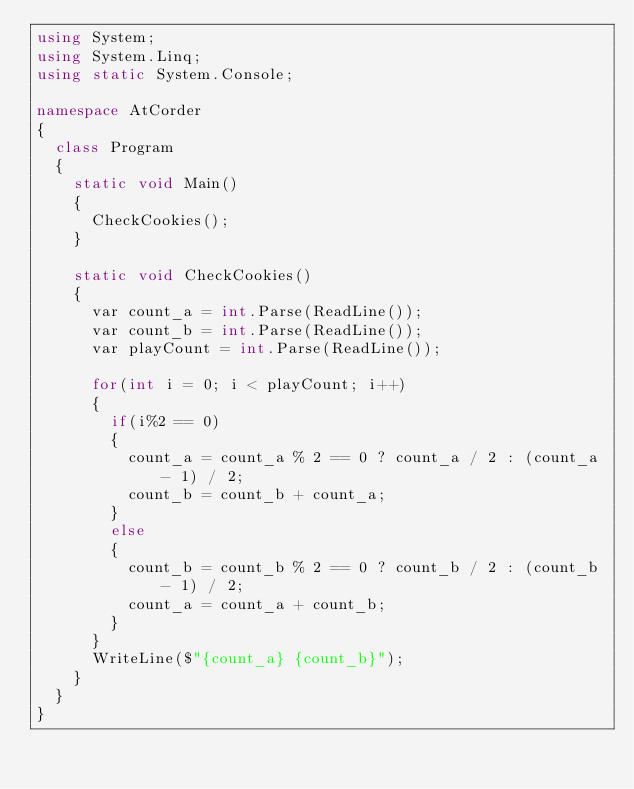<code> <loc_0><loc_0><loc_500><loc_500><_C#_>using System;
using System.Linq;
using static System.Console;

namespace AtCorder
{
  class Program
  {
    static void Main()
    {
      CheckCookies();
    }

    static void CheckCookies()
    {
      var count_a = int.Parse(ReadLine());
      var count_b = int.Parse(ReadLine());
      var playCount = int.Parse(ReadLine());

      for(int i = 0; i < playCount; i++)
      {
        if(i%2 == 0)
        {
          count_a = count_a % 2 == 0 ? count_a / 2 : (count_a - 1) / 2;
          count_b = count_b + count_a;
        } 
        else
        {
          count_b = count_b % 2 == 0 ? count_b / 2 : (count_b - 1) / 2;
          count_a = count_a + count_b;
        } 
      }
      WriteLine($"{count_a} {count_b}");
    }
  }
}</code> 